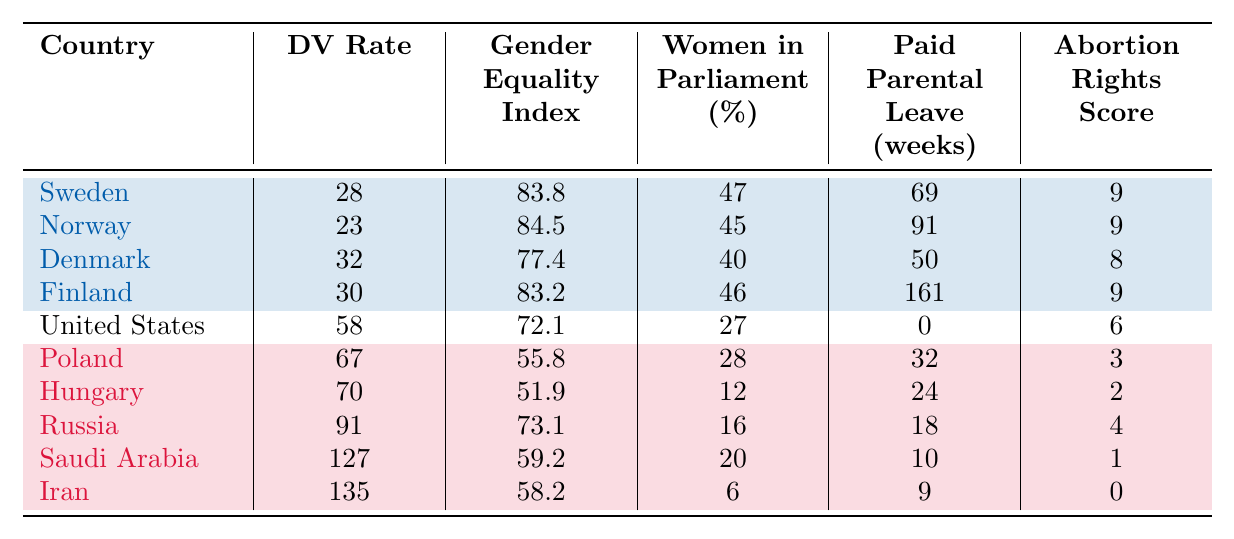What is the domestic violence rate in Sweden? The domestic violence rate for Sweden is listed in the table under the "DV Rate" column. It is specifically stated as 28 per 100,000.
Answer: 28 Which country has the highest gender equality index? The gender equality index is found in the "Gender Equality Index" column. By reviewing the values, Norway has the highest index at 84.5.
Answer: Norway What is the average domestic violence rate for countries with conservative policies? To find the average, we sum the domestic violence rates for Poland (67), Hungary (70), Russia (91), Saudi Arabia (127), and Iran (135): 67 + 70 + 91 + 127 + 135 = 490. Then we divide by the number of countries (5) to obtain 490 / 5 = 98.
Answer: 98 Is the percentage of women in parliament higher in Sweden or in the United States? The percentage of women in parliament for Sweden is 47%, while for the United States it is 27%. By comparing these values, it is clear that Sweden has a higher percentage.
Answer: Yes What is the total number of weeks of paid parental leave for progressive countries? For Sweden (69), Norway (91), Denmark (50), and Finland (161), we sum the paid parental leave weeks: 69 + 91 + 50 + 161 = 371 weeks.
Answer: 371 Which country has the lowest abortion rights score? By scanning the "Abortion Rights Score" column, we see that Iran has the lowest score listed as 0.
Answer: Iran How do the domestic violence rates compare between Finland and Poland? Finland has a domestic violence rate of 30 while Poland has 67. Comparing these two values indicates that Poland has a significantly higher rate than Finland.
Answer: Poland is higher What is the difference in the gender equality index between the highest and lowest-ranked countries in the table? The highest gender equality index is Norway with 84.5, and the lowest is Hungary with 51.9. We calculate the difference: 84.5 - 51.9 = 32.6.
Answer: 32.6 What percentage of women are in parliament in conservative countries compared to progressive countries? In progressive countries, the percentages are Sweden (47), Norway (45), Denmark (40), and Finland (46). The average for progressive is (47 + 45 + 40 + 46) / 4 = 44.5. In conservative countries, they are Poland (28), Hungary (12), Russia (16), Saudi Arabia (20), and Iran (6). The average for conservative is (28 + 12 + 16 + 20 + 6) / 5 = 16.4. Thus, the difference is 44.5 - 16.4 = 28.1.
Answer: 28.1 Which country has both a high domestic violence rate and low gender equality index? By reviewing the table, we note that Iran has a high domestic violence rate of 135 and a low gender equality index of 58.2.
Answer: Iran 